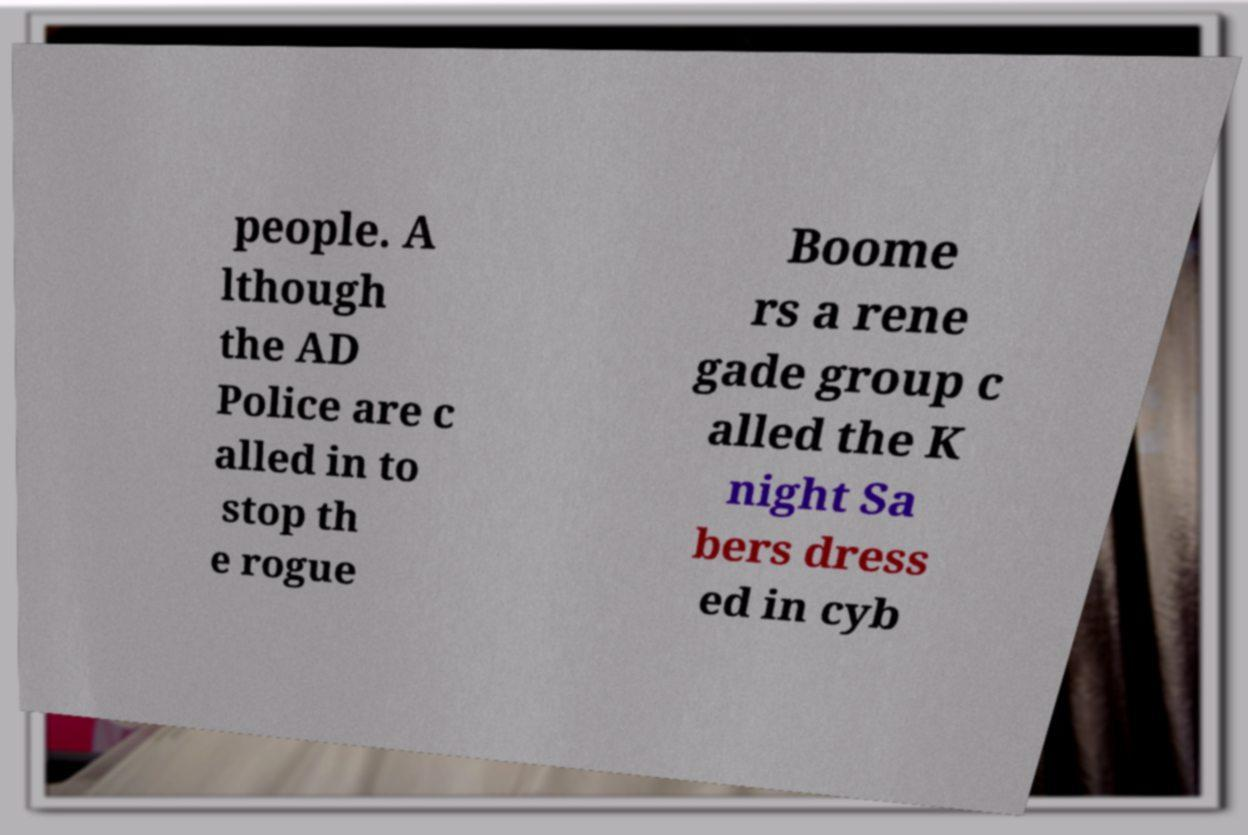There's text embedded in this image that I need extracted. Can you transcribe it verbatim? people. A lthough the AD Police are c alled in to stop th e rogue Boome rs a rene gade group c alled the K night Sa bers dress ed in cyb 